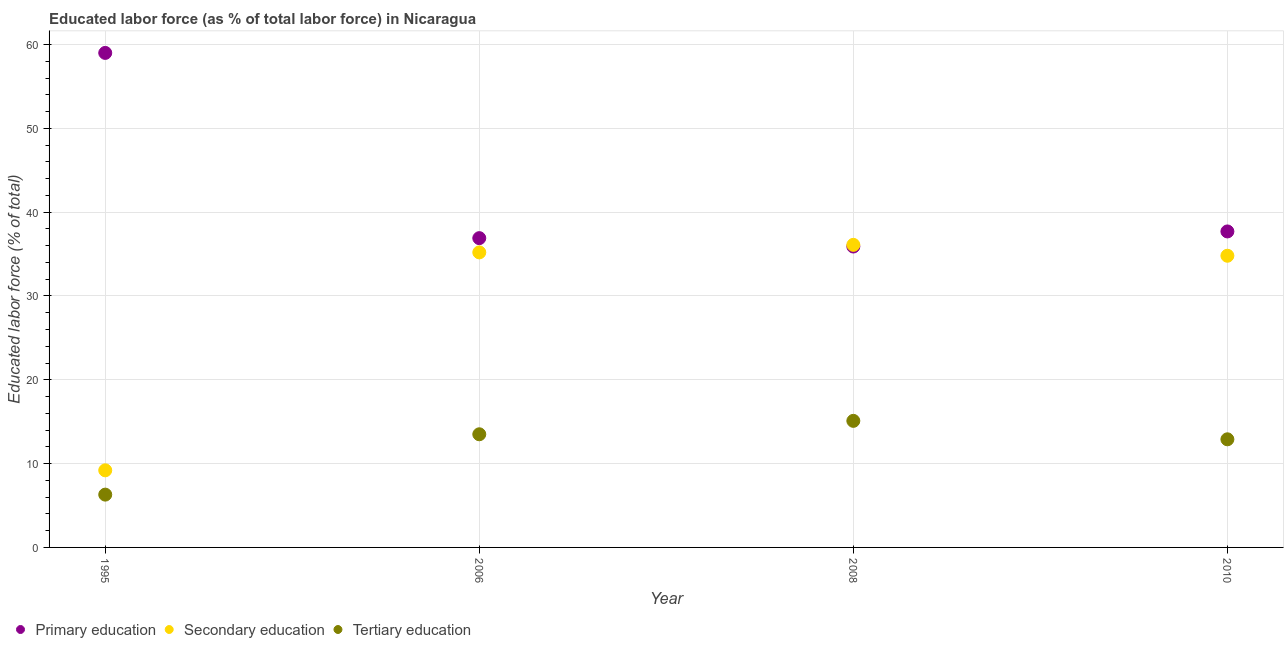What is the percentage of labor force who received secondary education in 2010?
Your response must be concise. 34.8. Across all years, what is the maximum percentage of labor force who received primary education?
Provide a succinct answer. 59. Across all years, what is the minimum percentage of labor force who received tertiary education?
Ensure brevity in your answer.  6.3. In which year was the percentage of labor force who received tertiary education minimum?
Ensure brevity in your answer.  1995. What is the total percentage of labor force who received tertiary education in the graph?
Ensure brevity in your answer.  47.8. What is the difference between the percentage of labor force who received tertiary education in 2006 and that in 2010?
Your answer should be very brief. 0.6. What is the difference between the percentage of labor force who received tertiary education in 2010 and the percentage of labor force who received primary education in 1995?
Offer a very short reply. -46.1. What is the average percentage of labor force who received secondary education per year?
Provide a succinct answer. 28.82. In the year 2006, what is the difference between the percentage of labor force who received primary education and percentage of labor force who received secondary education?
Provide a succinct answer. 1.7. What is the ratio of the percentage of labor force who received primary education in 2006 to that in 2010?
Provide a succinct answer. 0.98. Is the percentage of labor force who received primary education in 1995 less than that in 2008?
Your response must be concise. No. Is the difference between the percentage of labor force who received primary education in 2008 and 2010 greater than the difference between the percentage of labor force who received tertiary education in 2008 and 2010?
Offer a terse response. No. What is the difference between the highest and the second highest percentage of labor force who received tertiary education?
Provide a succinct answer. 1.6. What is the difference between the highest and the lowest percentage of labor force who received tertiary education?
Give a very brief answer. 8.8. Is it the case that in every year, the sum of the percentage of labor force who received primary education and percentage of labor force who received secondary education is greater than the percentage of labor force who received tertiary education?
Offer a very short reply. Yes. Does the percentage of labor force who received primary education monotonically increase over the years?
Provide a short and direct response. No. Is the percentage of labor force who received secondary education strictly less than the percentage of labor force who received primary education over the years?
Offer a terse response. No. Are the values on the major ticks of Y-axis written in scientific E-notation?
Keep it short and to the point. No. Does the graph contain any zero values?
Make the answer very short. No. Does the graph contain grids?
Provide a succinct answer. Yes. What is the title of the graph?
Provide a succinct answer. Educated labor force (as % of total labor force) in Nicaragua. What is the label or title of the X-axis?
Provide a short and direct response. Year. What is the label or title of the Y-axis?
Make the answer very short. Educated labor force (% of total). What is the Educated labor force (% of total) of Secondary education in 1995?
Keep it short and to the point. 9.2. What is the Educated labor force (% of total) of Tertiary education in 1995?
Give a very brief answer. 6.3. What is the Educated labor force (% of total) of Primary education in 2006?
Offer a very short reply. 36.9. What is the Educated labor force (% of total) in Secondary education in 2006?
Offer a terse response. 35.2. What is the Educated labor force (% of total) in Primary education in 2008?
Offer a terse response. 35.9. What is the Educated labor force (% of total) in Secondary education in 2008?
Keep it short and to the point. 36.1. What is the Educated labor force (% of total) of Tertiary education in 2008?
Ensure brevity in your answer.  15.1. What is the Educated labor force (% of total) of Primary education in 2010?
Provide a succinct answer. 37.7. What is the Educated labor force (% of total) of Secondary education in 2010?
Your answer should be compact. 34.8. What is the Educated labor force (% of total) of Tertiary education in 2010?
Your answer should be compact. 12.9. Across all years, what is the maximum Educated labor force (% of total) in Secondary education?
Offer a very short reply. 36.1. Across all years, what is the maximum Educated labor force (% of total) of Tertiary education?
Provide a short and direct response. 15.1. Across all years, what is the minimum Educated labor force (% of total) of Primary education?
Your answer should be very brief. 35.9. Across all years, what is the minimum Educated labor force (% of total) in Secondary education?
Your answer should be very brief. 9.2. Across all years, what is the minimum Educated labor force (% of total) of Tertiary education?
Make the answer very short. 6.3. What is the total Educated labor force (% of total) in Primary education in the graph?
Your answer should be very brief. 169.5. What is the total Educated labor force (% of total) of Secondary education in the graph?
Your answer should be very brief. 115.3. What is the total Educated labor force (% of total) of Tertiary education in the graph?
Your answer should be compact. 47.8. What is the difference between the Educated labor force (% of total) in Primary education in 1995 and that in 2006?
Provide a succinct answer. 22.1. What is the difference between the Educated labor force (% of total) of Tertiary education in 1995 and that in 2006?
Provide a short and direct response. -7.2. What is the difference between the Educated labor force (% of total) in Primary education in 1995 and that in 2008?
Provide a succinct answer. 23.1. What is the difference between the Educated labor force (% of total) in Secondary education in 1995 and that in 2008?
Offer a very short reply. -26.9. What is the difference between the Educated labor force (% of total) of Tertiary education in 1995 and that in 2008?
Keep it short and to the point. -8.8. What is the difference between the Educated labor force (% of total) of Primary education in 1995 and that in 2010?
Your answer should be very brief. 21.3. What is the difference between the Educated labor force (% of total) of Secondary education in 1995 and that in 2010?
Your answer should be compact. -25.6. What is the difference between the Educated labor force (% of total) of Primary education in 2006 and that in 2010?
Give a very brief answer. -0.8. What is the difference between the Educated labor force (% of total) in Tertiary education in 2006 and that in 2010?
Give a very brief answer. 0.6. What is the difference between the Educated labor force (% of total) in Primary education in 2008 and that in 2010?
Provide a succinct answer. -1.8. What is the difference between the Educated labor force (% of total) in Tertiary education in 2008 and that in 2010?
Provide a succinct answer. 2.2. What is the difference between the Educated labor force (% of total) in Primary education in 1995 and the Educated labor force (% of total) in Secondary education in 2006?
Provide a succinct answer. 23.8. What is the difference between the Educated labor force (% of total) in Primary education in 1995 and the Educated labor force (% of total) in Tertiary education in 2006?
Offer a very short reply. 45.5. What is the difference between the Educated labor force (% of total) in Primary education in 1995 and the Educated labor force (% of total) in Secondary education in 2008?
Your answer should be very brief. 22.9. What is the difference between the Educated labor force (% of total) in Primary education in 1995 and the Educated labor force (% of total) in Tertiary education in 2008?
Your answer should be very brief. 43.9. What is the difference between the Educated labor force (% of total) in Primary education in 1995 and the Educated labor force (% of total) in Secondary education in 2010?
Offer a very short reply. 24.2. What is the difference between the Educated labor force (% of total) of Primary education in 1995 and the Educated labor force (% of total) of Tertiary education in 2010?
Offer a terse response. 46.1. What is the difference between the Educated labor force (% of total) in Primary education in 2006 and the Educated labor force (% of total) in Secondary education in 2008?
Offer a very short reply. 0.8. What is the difference between the Educated labor force (% of total) of Primary education in 2006 and the Educated labor force (% of total) of Tertiary education in 2008?
Keep it short and to the point. 21.8. What is the difference between the Educated labor force (% of total) in Secondary education in 2006 and the Educated labor force (% of total) in Tertiary education in 2008?
Your answer should be compact. 20.1. What is the difference between the Educated labor force (% of total) of Primary education in 2006 and the Educated labor force (% of total) of Secondary education in 2010?
Give a very brief answer. 2.1. What is the difference between the Educated labor force (% of total) in Secondary education in 2006 and the Educated labor force (% of total) in Tertiary education in 2010?
Your answer should be compact. 22.3. What is the difference between the Educated labor force (% of total) in Primary education in 2008 and the Educated labor force (% of total) in Tertiary education in 2010?
Your answer should be very brief. 23. What is the difference between the Educated labor force (% of total) in Secondary education in 2008 and the Educated labor force (% of total) in Tertiary education in 2010?
Offer a very short reply. 23.2. What is the average Educated labor force (% of total) of Primary education per year?
Your answer should be compact. 42.38. What is the average Educated labor force (% of total) of Secondary education per year?
Your answer should be compact. 28.82. What is the average Educated labor force (% of total) of Tertiary education per year?
Offer a very short reply. 11.95. In the year 1995, what is the difference between the Educated labor force (% of total) of Primary education and Educated labor force (% of total) of Secondary education?
Make the answer very short. 49.8. In the year 1995, what is the difference between the Educated labor force (% of total) in Primary education and Educated labor force (% of total) in Tertiary education?
Provide a succinct answer. 52.7. In the year 2006, what is the difference between the Educated labor force (% of total) in Primary education and Educated labor force (% of total) in Secondary education?
Ensure brevity in your answer.  1.7. In the year 2006, what is the difference between the Educated labor force (% of total) in Primary education and Educated labor force (% of total) in Tertiary education?
Give a very brief answer. 23.4. In the year 2006, what is the difference between the Educated labor force (% of total) in Secondary education and Educated labor force (% of total) in Tertiary education?
Your answer should be very brief. 21.7. In the year 2008, what is the difference between the Educated labor force (% of total) of Primary education and Educated labor force (% of total) of Secondary education?
Offer a very short reply. -0.2. In the year 2008, what is the difference between the Educated labor force (% of total) of Primary education and Educated labor force (% of total) of Tertiary education?
Offer a very short reply. 20.8. In the year 2010, what is the difference between the Educated labor force (% of total) of Primary education and Educated labor force (% of total) of Secondary education?
Offer a terse response. 2.9. In the year 2010, what is the difference between the Educated labor force (% of total) of Primary education and Educated labor force (% of total) of Tertiary education?
Provide a short and direct response. 24.8. In the year 2010, what is the difference between the Educated labor force (% of total) of Secondary education and Educated labor force (% of total) of Tertiary education?
Your answer should be compact. 21.9. What is the ratio of the Educated labor force (% of total) of Primary education in 1995 to that in 2006?
Provide a short and direct response. 1.6. What is the ratio of the Educated labor force (% of total) in Secondary education in 1995 to that in 2006?
Your response must be concise. 0.26. What is the ratio of the Educated labor force (% of total) of Tertiary education in 1995 to that in 2006?
Keep it short and to the point. 0.47. What is the ratio of the Educated labor force (% of total) of Primary education in 1995 to that in 2008?
Your answer should be compact. 1.64. What is the ratio of the Educated labor force (% of total) of Secondary education in 1995 to that in 2008?
Make the answer very short. 0.25. What is the ratio of the Educated labor force (% of total) of Tertiary education in 1995 to that in 2008?
Ensure brevity in your answer.  0.42. What is the ratio of the Educated labor force (% of total) in Primary education in 1995 to that in 2010?
Offer a very short reply. 1.56. What is the ratio of the Educated labor force (% of total) of Secondary education in 1995 to that in 2010?
Your answer should be compact. 0.26. What is the ratio of the Educated labor force (% of total) in Tertiary education in 1995 to that in 2010?
Your response must be concise. 0.49. What is the ratio of the Educated labor force (% of total) of Primary education in 2006 to that in 2008?
Ensure brevity in your answer.  1.03. What is the ratio of the Educated labor force (% of total) of Secondary education in 2006 to that in 2008?
Your answer should be compact. 0.98. What is the ratio of the Educated labor force (% of total) in Tertiary education in 2006 to that in 2008?
Provide a short and direct response. 0.89. What is the ratio of the Educated labor force (% of total) in Primary education in 2006 to that in 2010?
Your response must be concise. 0.98. What is the ratio of the Educated labor force (% of total) in Secondary education in 2006 to that in 2010?
Make the answer very short. 1.01. What is the ratio of the Educated labor force (% of total) of Tertiary education in 2006 to that in 2010?
Your answer should be very brief. 1.05. What is the ratio of the Educated labor force (% of total) of Primary education in 2008 to that in 2010?
Provide a short and direct response. 0.95. What is the ratio of the Educated labor force (% of total) in Secondary education in 2008 to that in 2010?
Provide a short and direct response. 1.04. What is the ratio of the Educated labor force (% of total) of Tertiary education in 2008 to that in 2010?
Your answer should be compact. 1.17. What is the difference between the highest and the second highest Educated labor force (% of total) in Primary education?
Give a very brief answer. 21.3. What is the difference between the highest and the second highest Educated labor force (% of total) in Tertiary education?
Offer a terse response. 1.6. What is the difference between the highest and the lowest Educated labor force (% of total) in Primary education?
Make the answer very short. 23.1. What is the difference between the highest and the lowest Educated labor force (% of total) in Secondary education?
Your response must be concise. 26.9. What is the difference between the highest and the lowest Educated labor force (% of total) in Tertiary education?
Your answer should be compact. 8.8. 